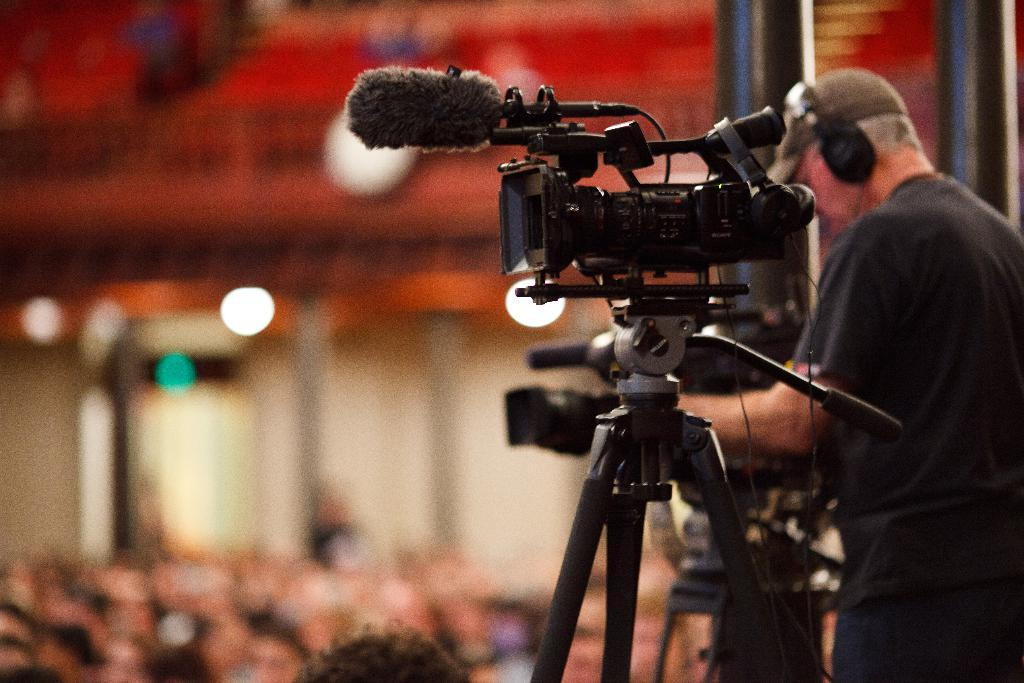What is the main subject of the image? There is a man standing in the image. What is the man wearing on his ears? The man is wearing headphones. What type of hat is the man wearing? The man is wearing a cap. What device can be seen in the image? There is a video camera in the image. How would you describe the background of the image? The background of the image is blurred. What type of poison is the man using to cook on the stove in the image? There is no stove or poison present in the image; it only features a man standing, wearing headphones and a cap, with a blurred background and a video camera. 